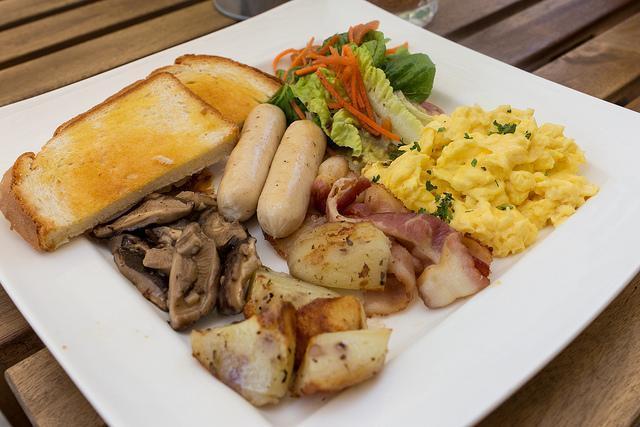How many pieces of toast are there?
Give a very brief answer. 2. How many hot dogs are in the picture?
Give a very brief answer. 2. How many motorcycles are pictured?
Give a very brief answer. 0. 